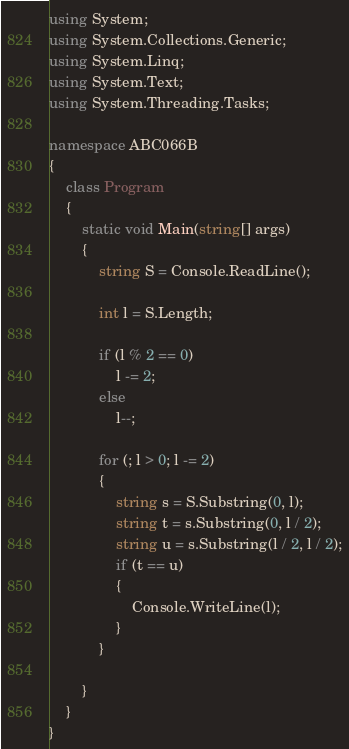<code> <loc_0><loc_0><loc_500><loc_500><_C#_>using System;
using System.Collections.Generic;
using System.Linq;
using System.Text;
using System.Threading.Tasks;

namespace ABC066B
{
    class Program
    {
        static void Main(string[] args)
        {
            string S = Console.ReadLine();

            int l = S.Length;

            if (l % 2 == 0)
                l -= 2;
            else
                l--;

            for (; l > 0; l -= 2)
            {
                string s = S.Substring(0, l);
                string t = s.Substring(0, l / 2);
                string u = s.Substring(l / 2, l / 2);
                if (t == u)
                {
                    Console.WriteLine(l);
                }
            }

        }
    }
}
</code> 